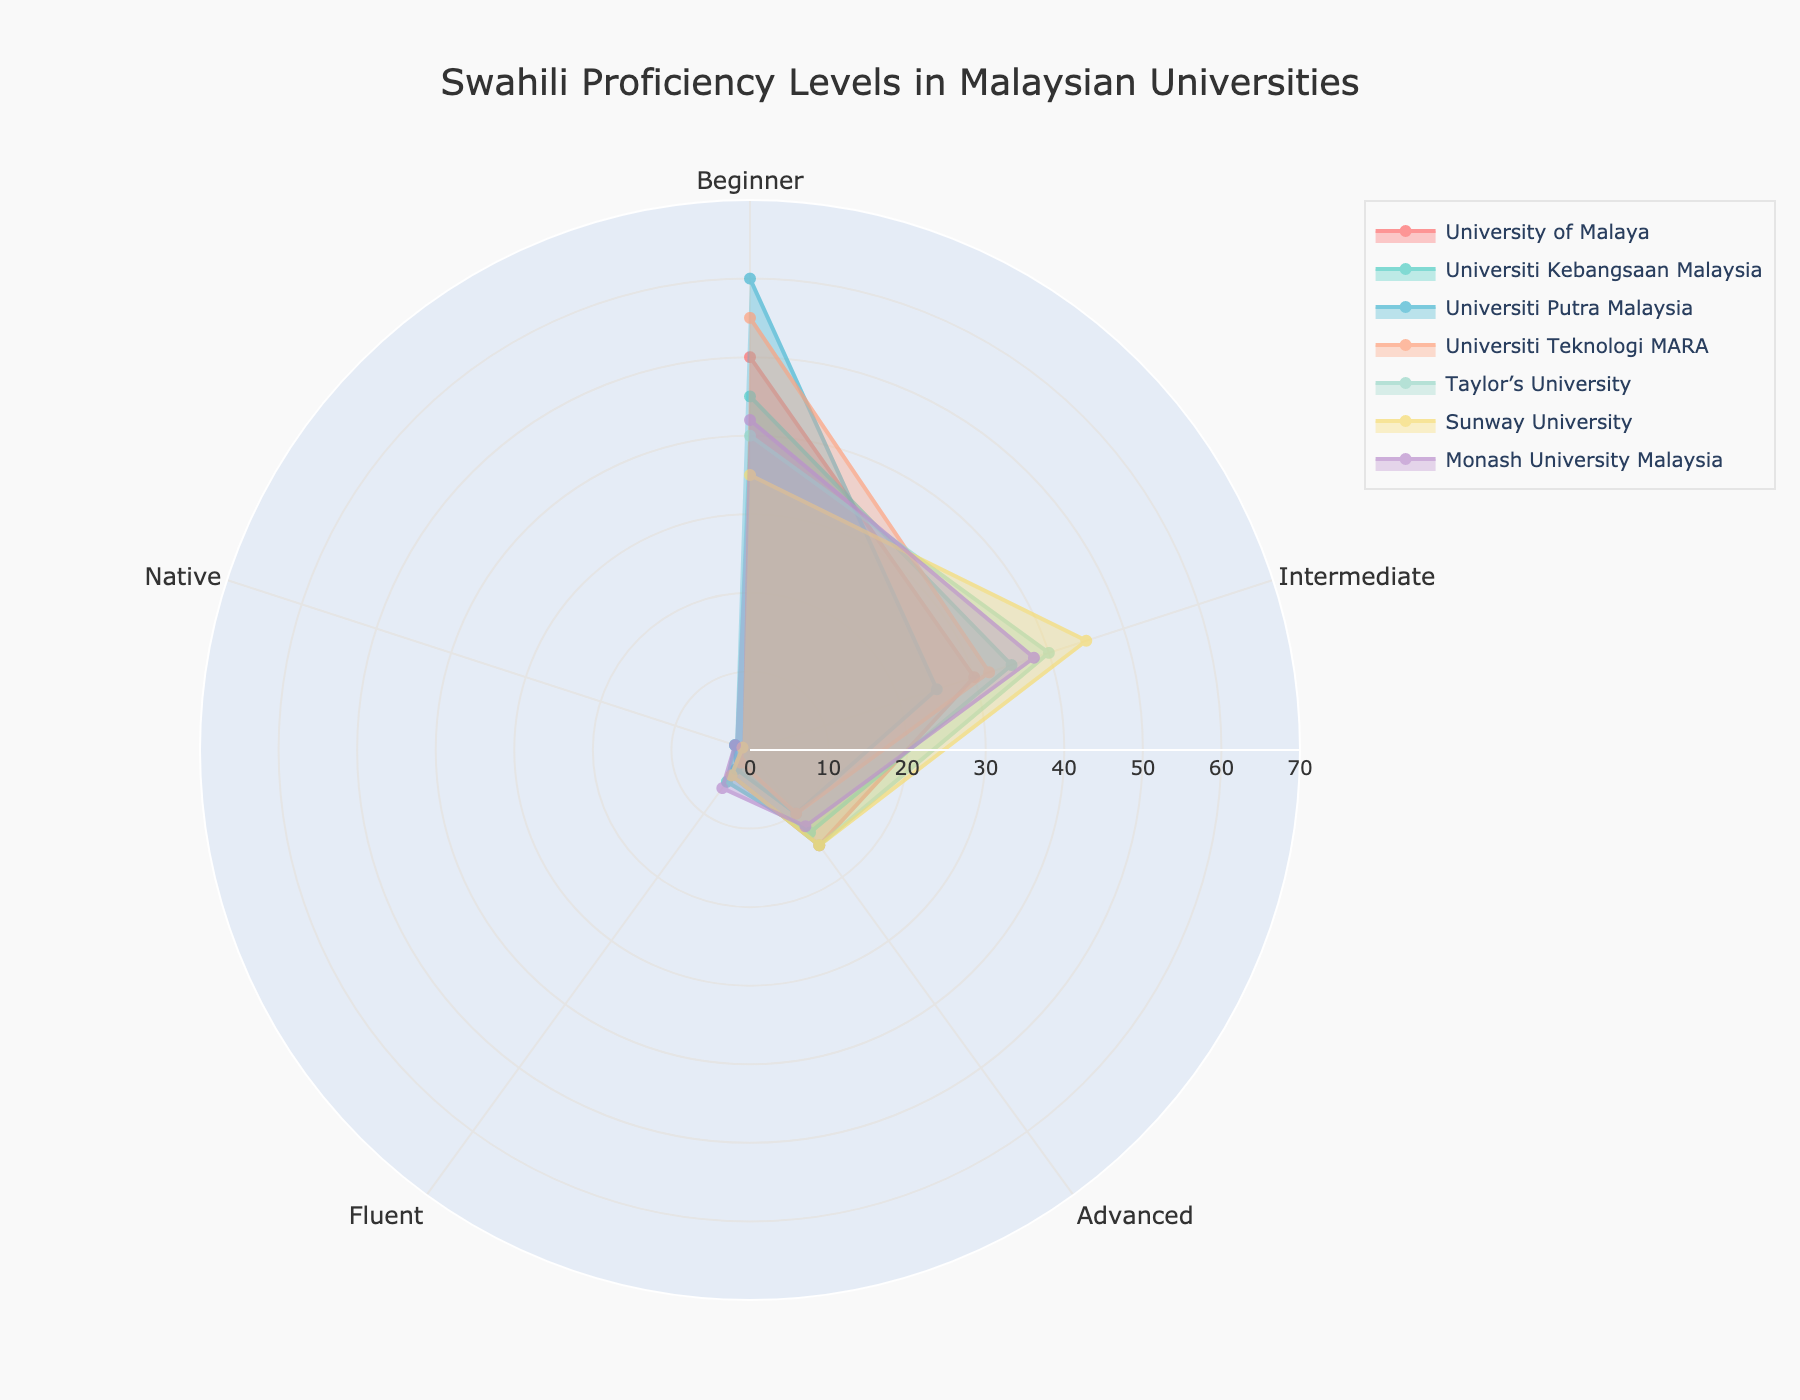How many proficiency levels are displayed in the figure? The figure has five proficiency levels, which can be determined by identifying the categories listed in the legend or axes.
Answer: Five Which university has the highest number of beginner Swahili learners? To find this information, look at the values corresponding to the "Beginner" category for each university and identify the highest value.
Answer: Universiti Putra Malaysia Compare the number of intermediate learners at University of Malaya and Sunway University. Which one has more? Review the values for "Intermediate" learners for both University of Malaya and Sunway University. University of Malaya has 30 while Sunway University has 45.
Answer: Sunway University How does the number of fluent learners at Monash University Malaysia compare to the number of fluent learners at Universiti Kebangsaan Malaysia and Taylor’s University combined? Monash University Malaysia has 6 fluent learners. Universiti Kebangsaan Malaysia has 5, and Taylor’s University has 4. Adding the latter two gives 9. Thus, Monash has fewer fluent learners compared to the combined total.
Answer: Fewer Which university has the most evenly distributed proficiency levels? Look for the university with the most equal values across all proficiency levels. Sunway University has the most balanced distribution with values 35, 45, 15, 4, 1.
Answer: Sunway University What is the combined total of advanced learners at all universities? Sum the values of "Advanced" learners across all universities: 15 + 13 + 10 + 10 + 15 + 15 + 12 equals 90.
Answer: 90 Identify the university with the least number of native Swahili speakers. Check the values under the "Native" category for all universities and find the lowest number. Several universities, including University of Malaya, Universiti Teknologi MARA, Taylor’s University, and Sunway University, have 1 native speaker.
Answer: University of Malaya, Universiti Teknologi MARA, Taylor’s University, Sunway University What is the difference between the number of beginner learners at Universiti Putra Malaysia and Taylor’s University? Universiti Putra Malaysia has 60 beginner learners, while Taylor’s University has 40. The difference is 60 - 40, which equals 20.
Answer: 20 How does the number of advanced learners at Universiti Putra Malaysia compare to those at University of Malaya and Universiti Kebangsaan Malaysia? Universiti Putra Malaysia has 10 advanced learners. University of Malaya has 15, and Universiti Kebangsaan Malaysia has 13. Hence, Universiti Putra Malaysia has fewer advanced learners.
Answer: Fewer 